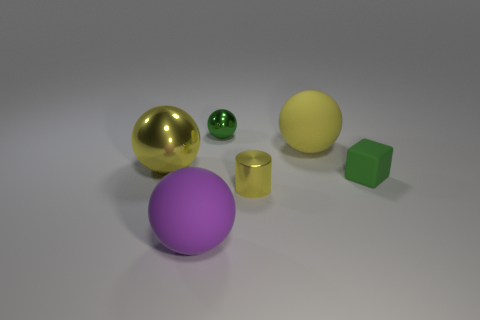Is the number of shiny objects to the left of the large yellow metallic thing the same as the number of purple spheres?
Give a very brief answer. No. What material is the big yellow object that is behind the metal sphere in front of the big rubber sphere behind the large purple rubber ball made of?
Offer a terse response. Rubber. What color is the rubber sphere in front of the yellow metallic cylinder?
Ensure brevity in your answer.  Purple. Is there anything else that has the same shape as the small green rubber thing?
Provide a succinct answer. No. What is the size of the metal thing that is to the left of the small metallic sphere that is to the left of the yellow rubber ball?
Give a very brief answer. Large. Are there the same number of green blocks that are left of the green rubber thing and tiny green things to the left of the yellow rubber thing?
Give a very brief answer. No. What color is the large object that is the same material as the tiny cylinder?
Your answer should be compact. Yellow. Is the green cube made of the same material as the big yellow object that is to the right of the tiny green metal sphere?
Offer a terse response. Yes. There is a sphere that is both behind the purple matte ball and on the left side of the green shiny sphere; what is its color?
Offer a terse response. Yellow. What number of cylinders are tiny yellow metallic objects or large yellow metallic things?
Your answer should be very brief. 1. 